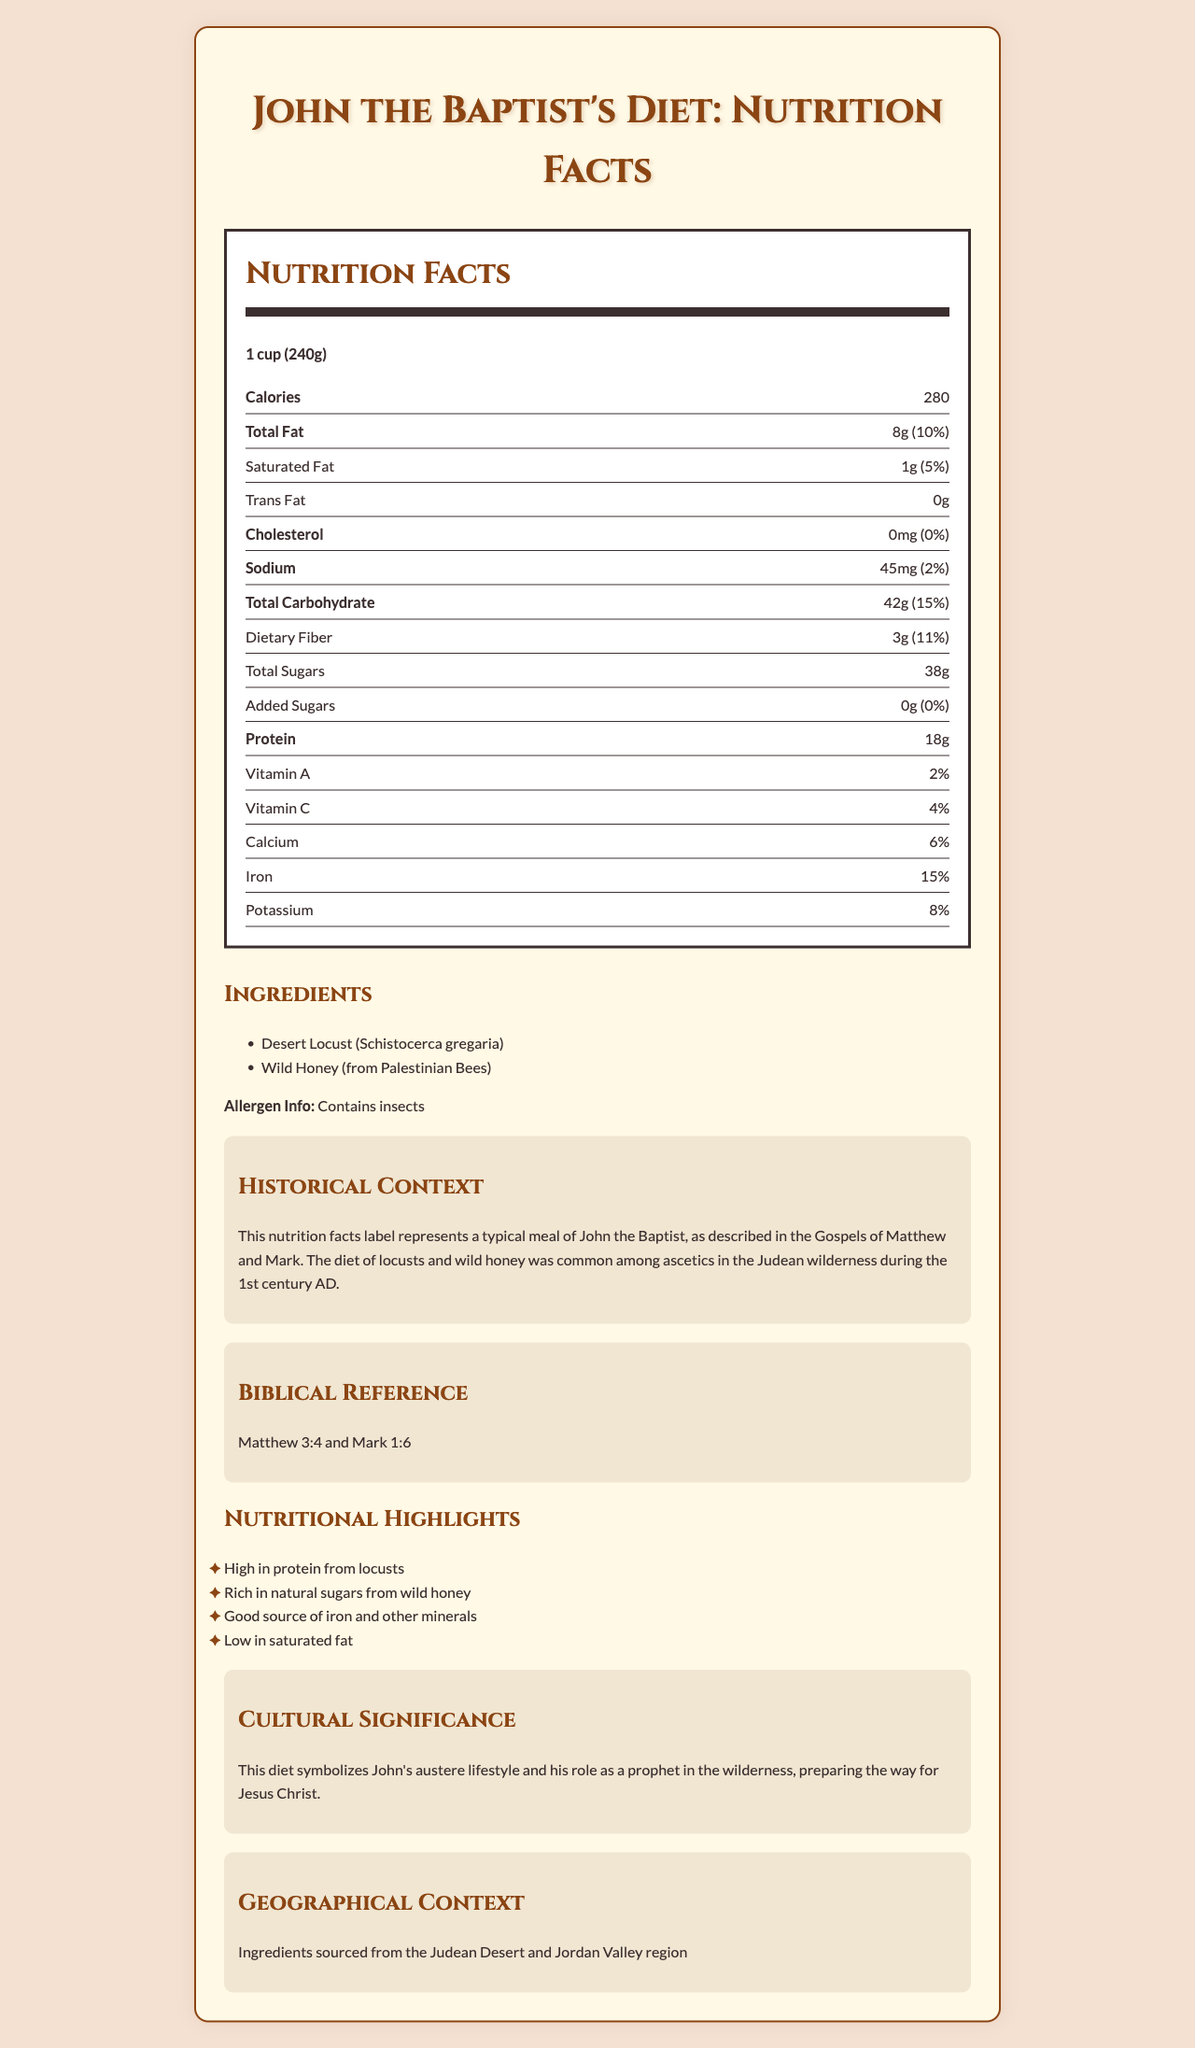what is the serving size of John the Baptist's diet? The serving size is clearly listed under "Nutrition Facts" as "1 cup (240g)".
Answer: 1 cup (240g) how many calories are in one serving of John the Baptist's diet? The number of calories per serving is listed as 280 under the "Nutrition Facts" section.
Answer: 280 what is the amount of protein in John the Baptist's diet per serving? The amount of protein is mentioned as 18g under the "Nutrition Facts" details.
Answer: 18g how much dietary fiber does John the Baptist's diet contain per serving? The dietary fiber content is listed as 3g under the "Nutrition Facts" section.
Answer: 3g what percentage of daily iron is provided in one serving? The iron content percentage is shown to be 15% in the "Nutrition Facts" section.
Answer: 15% which ingredients are listed for this diet? A. Desert Locust B. Wild Honey C. Both Desert Locust & Wild Honey D. None The ingredients listed are "Desert Locust (Schistocerca gregaria)" and "Wild Honey (from Palestinian Bees)".
Answer: C how much total carbohydrate is there per serving? A. 42g B. 15g C. 8g D. 280g The "Total Carbohydrate" amount is listed as 42g under "Nutrition Facts".
Answer: A is the diet high in saturated fat? The saturated fat content is 1g, which is only 5% of the daily value, making it low in saturated fat.
Answer: No what are the main nutritional highlights of this diet? The highlights are outlined in the "Nutritional Highlights" section.
Answer: High in protein, Rich in natural sugars, Good source of iron and other minerals, Low in saturated fat acknowledge the cultural significance of this diet? This information is stated under the "Cultural Significance" section.
Answer: Symbolizes John's austere lifestyle and his role as a prophet in the wilderness, preparing the way for Jesus Christ what is the sodium content per serving? The sodium content is listed as 45mg in the "Nutrition Facts".
Answer: 45mg Describe the main idea of the document The document goes into detail about the components and significance of John the Baptist's diet, portraying it in a nutritional context.
Answer: The document provides the nutritional facts, ingredients, historical context, cultural significance, and geographical source information about the diet of John the Baptist, focusing on his consumption of locusts and wild honey. It highlights nutritional benefits, context from the Bible, and the diet’s symbolic meaning. where was John the Baptist's diet sourced from? The geographical sourcing information is provided in the "Geographical Context" section.
Answer: Judean Desert and Jordan Valley region compare the amount of vitamin A and vitamin C in a serving The "Nutrition Facts" section lists vitamin A as 2% and vitamin C as 4%.
Answer: Vitamin A: 2%, Vitamin C: 4% why was this diet significant historically? The "Historical Context" section provides this information, explaining how it reflects the practices of asceticism in that era.
Answer: It was common among ascetics in the Judean wilderness during the 1st century AD, representing an austere lifestyle. what is John the Baptist's diet described in biblical references? A. Luke 1:10 B. John 2:1 C. Matthew 3:4 and Mark 1:6 D. Genesis 1:1 The biblical references provided are "Matthew 3:4 and Mark 1:6," describing John the Baptist's diet.
Answer: C what is the total amount of sugars in one serving? The total sugars content is listed as 38g under the "Nutrition Facts" section.
Answer: 38g Does the document provide specific historical events related to the diet? The document provides general historical context about the diet's commonality among ascetics but does not list specific historical events.
Answer: No 